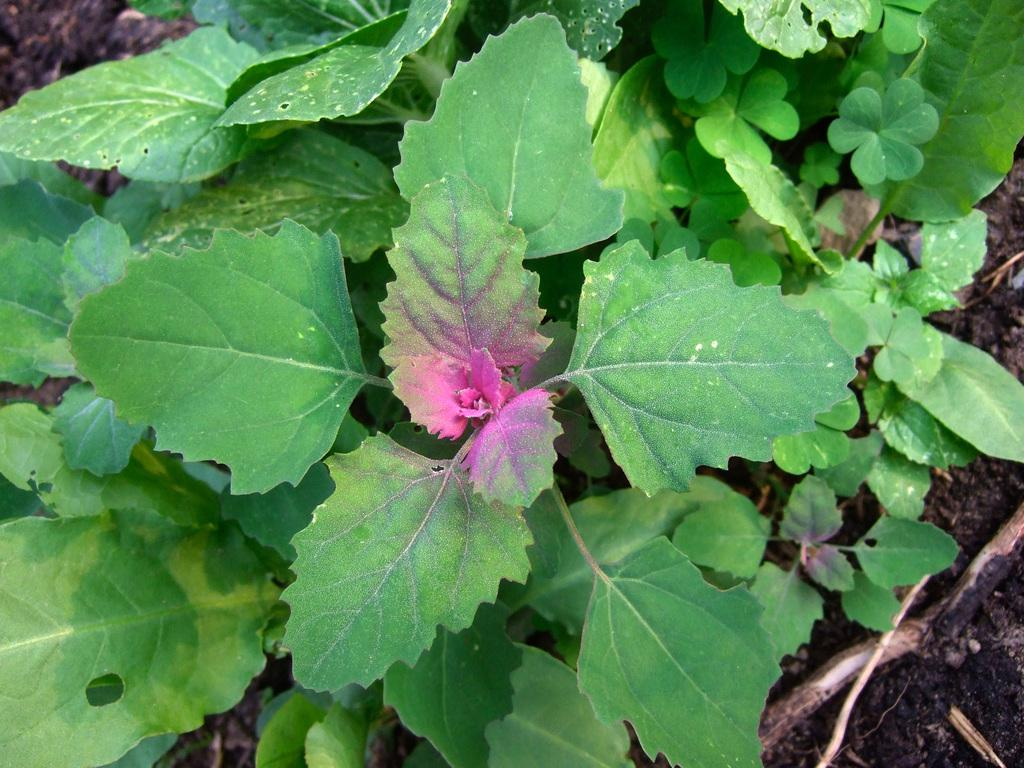What type of plants can be seen in the image? There are green plants in the image. What type of stove is visible in the image? There is no stove present in the image; it only features green plants. What type of can is shown next to the plants in the image? There is no can present in the image; it only features green plants. 